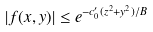<formula> <loc_0><loc_0><loc_500><loc_500>| f ( x , y ) | \leq e ^ { - c _ { 0 } ^ { \prime } ( z ^ { 2 } + y ^ { 2 } ) / B }</formula> 